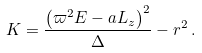<formula> <loc_0><loc_0><loc_500><loc_500>K = \frac { \left ( \varpi ^ { 2 } E - a L _ { z } \right ) ^ { 2 } } { \Delta } - r ^ { 2 } \, .</formula> 